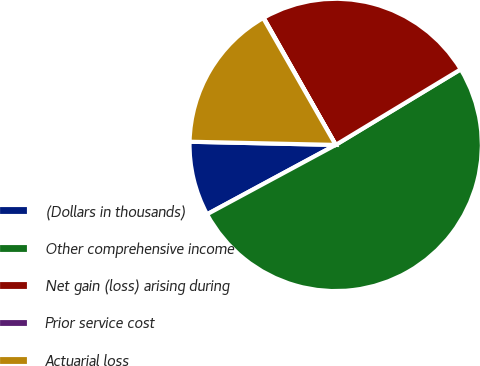Convert chart to OTSL. <chart><loc_0><loc_0><loc_500><loc_500><pie_chart><fcel>(Dollars in thousands)<fcel>Other comprehensive income<fcel>Net gain (loss) arising during<fcel>Prior service cost<fcel>Actuarial loss<nl><fcel>8.22%<fcel>50.79%<fcel>24.56%<fcel>0.05%<fcel>16.39%<nl></chart> 